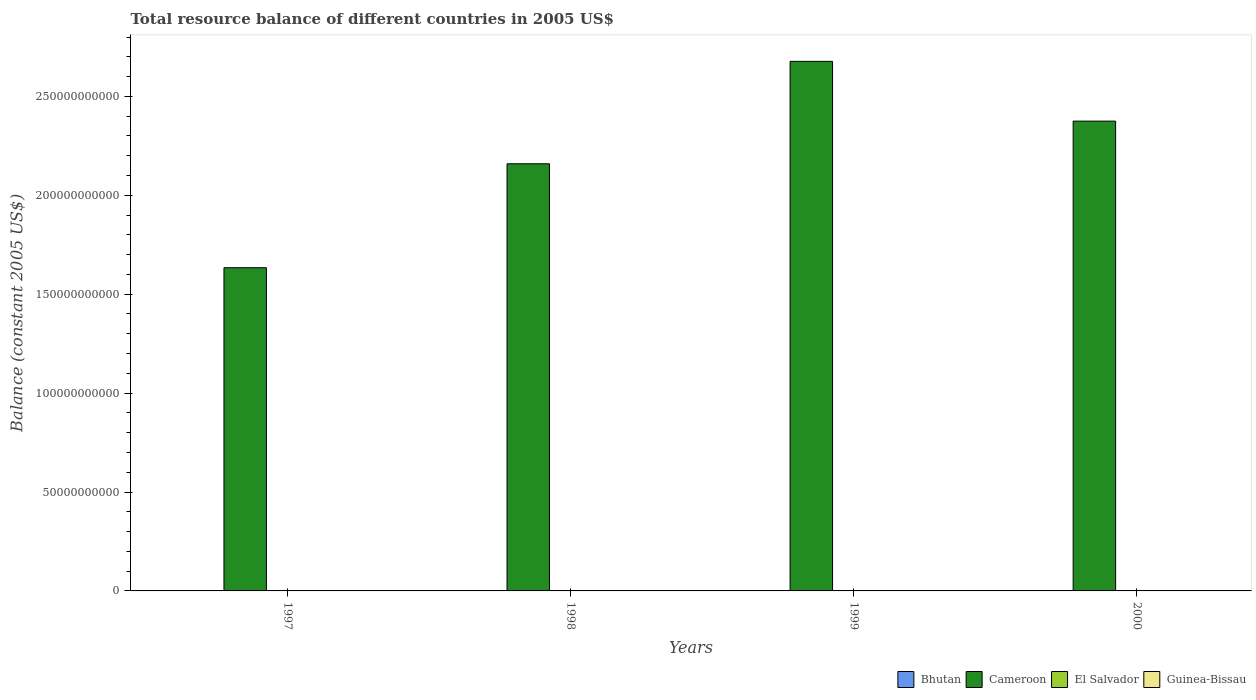How many different coloured bars are there?
Offer a terse response. 1. What is the total resource balance in Guinea-Bissau in 1998?
Give a very brief answer. 0. What is the difference between the total resource balance in Cameroon in 1998 and the total resource balance in Bhutan in 1999?
Provide a short and direct response. 2.16e+11. What is the average total resource balance in Bhutan per year?
Your answer should be very brief. 0. Is the total resource balance in Cameroon in 1997 less than that in 2000?
Offer a very short reply. Yes. What is the difference between the highest and the second highest total resource balance in Cameroon?
Make the answer very short. 3.02e+1. What is the difference between the highest and the lowest total resource balance in Cameroon?
Your answer should be compact. 1.04e+11. Is the sum of the total resource balance in Cameroon in 1997 and 2000 greater than the maximum total resource balance in Guinea-Bissau across all years?
Keep it short and to the point. Yes. Is it the case that in every year, the sum of the total resource balance in El Salvador and total resource balance in Bhutan is greater than the sum of total resource balance in Cameroon and total resource balance in Guinea-Bissau?
Your answer should be compact. No. Is it the case that in every year, the sum of the total resource balance in El Salvador and total resource balance in Bhutan is greater than the total resource balance in Cameroon?
Give a very brief answer. No. Are all the bars in the graph horizontal?
Give a very brief answer. No. How many years are there in the graph?
Make the answer very short. 4. Are the values on the major ticks of Y-axis written in scientific E-notation?
Ensure brevity in your answer.  No. Does the graph contain any zero values?
Provide a short and direct response. Yes. Does the graph contain grids?
Keep it short and to the point. No. Where does the legend appear in the graph?
Your answer should be very brief. Bottom right. How many legend labels are there?
Keep it short and to the point. 4. What is the title of the graph?
Offer a terse response. Total resource balance of different countries in 2005 US$. Does "St. Kitts and Nevis" appear as one of the legend labels in the graph?
Your answer should be compact. No. What is the label or title of the Y-axis?
Your response must be concise. Balance (constant 2005 US$). What is the Balance (constant 2005 US$) in Cameroon in 1997?
Keep it short and to the point. 1.63e+11. What is the Balance (constant 2005 US$) of El Salvador in 1997?
Provide a succinct answer. 0. What is the Balance (constant 2005 US$) in Guinea-Bissau in 1997?
Ensure brevity in your answer.  0. What is the Balance (constant 2005 US$) in Cameroon in 1998?
Keep it short and to the point. 2.16e+11. What is the Balance (constant 2005 US$) of El Salvador in 1998?
Offer a very short reply. 0. What is the Balance (constant 2005 US$) of Bhutan in 1999?
Keep it short and to the point. 0. What is the Balance (constant 2005 US$) in Cameroon in 1999?
Your answer should be compact. 2.68e+11. What is the Balance (constant 2005 US$) in El Salvador in 1999?
Give a very brief answer. 0. What is the Balance (constant 2005 US$) of Bhutan in 2000?
Provide a short and direct response. 0. What is the Balance (constant 2005 US$) in Cameroon in 2000?
Your answer should be very brief. 2.37e+11. Across all years, what is the maximum Balance (constant 2005 US$) in Cameroon?
Keep it short and to the point. 2.68e+11. Across all years, what is the minimum Balance (constant 2005 US$) in Cameroon?
Provide a short and direct response. 1.63e+11. What is the total Balance (constant 2005 US$) in Cameroon in the graph?
Make the answer very short. 8.84e+11. What is the total Balance (constant 2005 US$) of Guinea-Bissau in the graph?
Provide a succinct answer. 0. What is the difference between the Balance (constant 2005 US$) in Cameroon in 1997 and that in 1998?
Offer a very short reply. -5.25e+1. What is the difference between the Balance (constant 2005 US$) in Cameroon in 1997 and that in 1999?
Provide a short and direct response. -1.04e+11. What is the difference between the Balance (constant 2005 US$) in Cameroon in 1997 and that in 2000?
Offer a very short reply. -7.41e+1. What is the difference between the Balance (constant 2005 US$) in Cameroon in 1998 and that in 1999?
Your answer should be compact. -5.18e+1. What is the difference between the Balance (constant 2005 US$) of Cameroon in 1998 and that in 2000?
Offer a very short reply. -2.16e+1. What is the difference between the Balance (constant 2005 US$) in Cameroon in 1999 and that in 2000?
Provide a succinct answer. 3.02e+1. What is the average Balance (constant 2005 US$) in Bhutan per year?
Give a very brief answer. 0. What is the average Balance (constant 2005 US$) in Cameroon per year?
Offer a terse response. 2.21e+11. What is the average Balance (constant 2005 US$) of El Salvador per year?
Provide a succinct answer. 0. What is the ratio of the Balance (constant 2005 US$) of Cameroon in 1997 to that in 1998?
Ensure brevity in your answer.  0.76. What is the ratio of the Balance (constant 2005 US$) of Cameroon in 1997 to that in 1999?
Provide a short and direct response. 0.61. What is the ratio of the Balance (constant 2005 US$) of Cameroon in 1997 to that in 2000?
Make the answer very short. 0.69. What is the ratio of the Balance (constant 2005 US$) of Cameroon in 1998 to that in 1999?
Provide a short and direct response. 0.81. What is the ratio of the Balance (constant 2005 US$) in Cameroon in 1998 to that in 2000?
Your answer should be very brief. 0.91. What is the ratio of the Balance (constant 2005 US$) in Cameroon in 1999 to that in 2000?
Your answer should be very brief. 1.13. What is the difference between the highest and the second highest Balance (constant 2005 US$) of Cameroon?
Your response must be concise. 3.02e+1. What is the difference between the highest and the lowest Balance (constant 2005 US$) of Cameroon?
Offer a very short reply. 1.04e+11. 